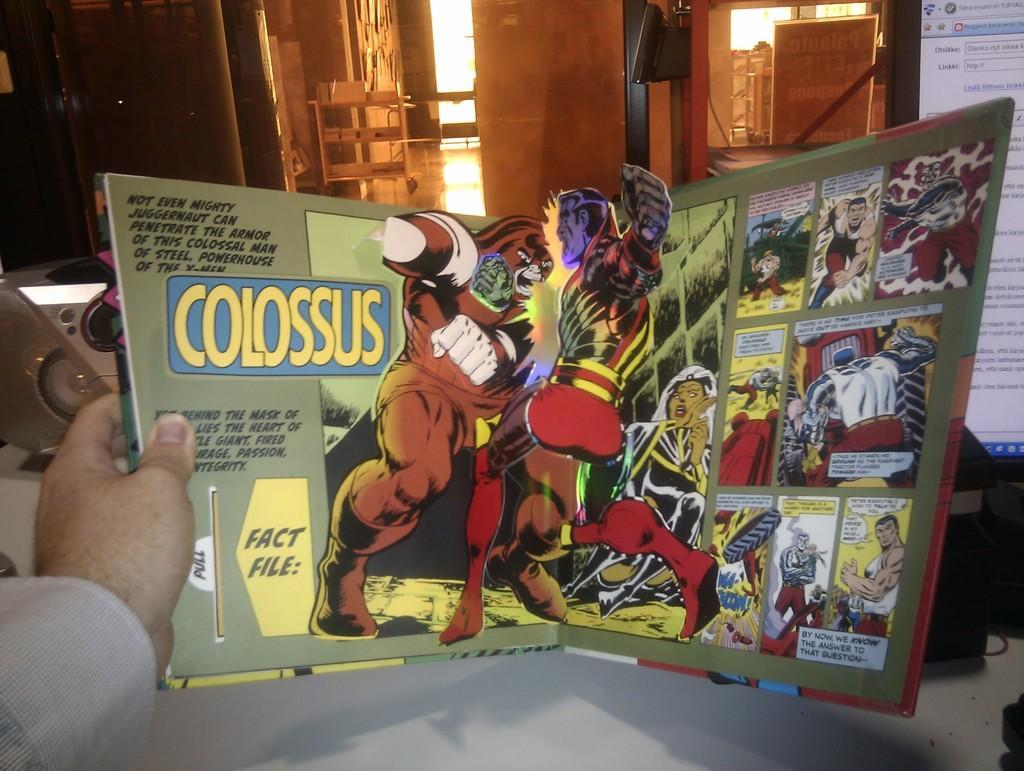Describe this image in one or two sentences. In this image, at the bottom there is a person hand, holding a book on that there are cartoons and text. In the background there is a monitor, screen, machine, building, windows, objects and a wall. 